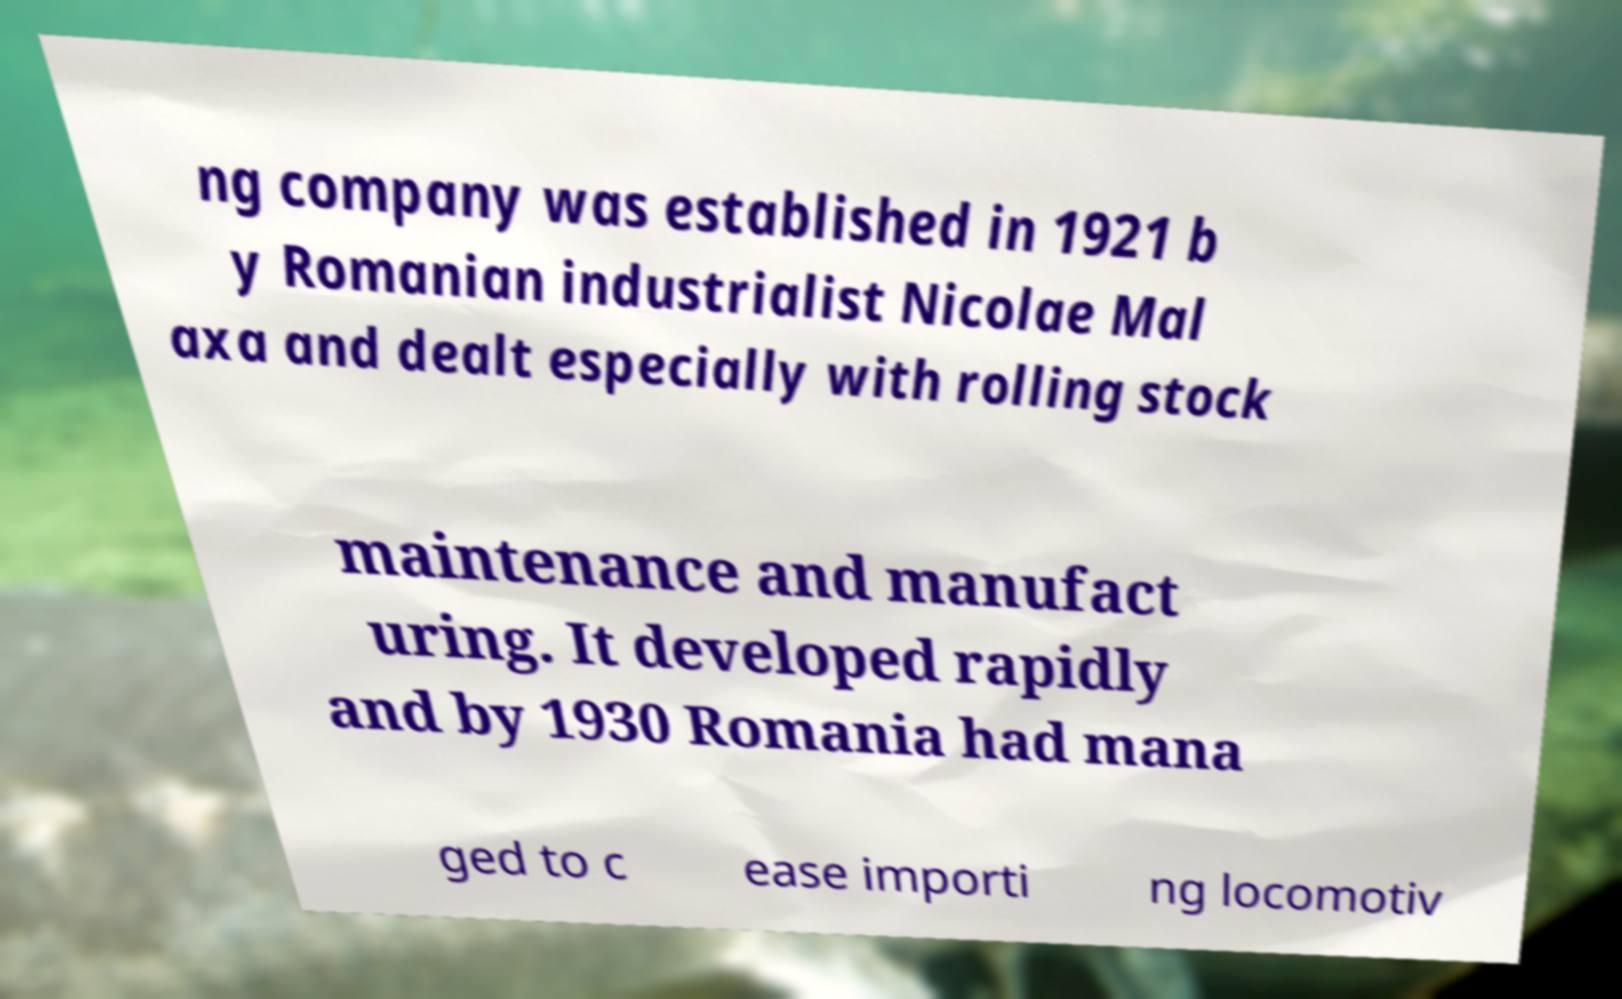Please read and relay the text visible in this image. What does it say? ng company was established in 1921 b y Romanian industrialist Nicolae Mal axa and dealt especially with rolling stock maintenance and manufact uring. It developed rapidly and by 1930 Romania had mana ged to c ease importi ng locomotiv 